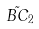<formula> <loc_0><loc_0><loc_500><loc_500>\tilde { B C } _ { 2 }</formula> 